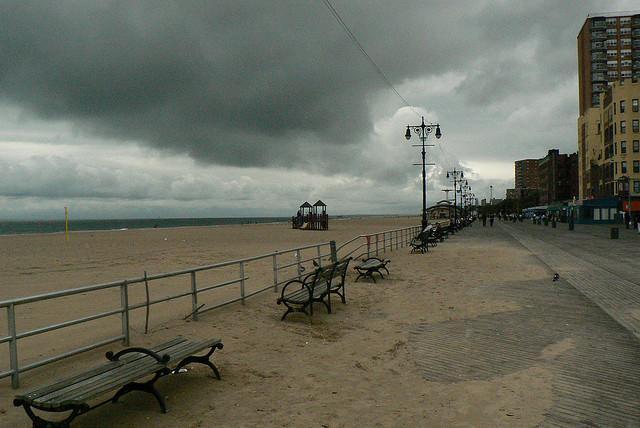Why is the beach empty?
Select the accurate response from the four choices given to answer the question.
Options: Pollution, storm coming, work day, lockdown. Storm coming. 